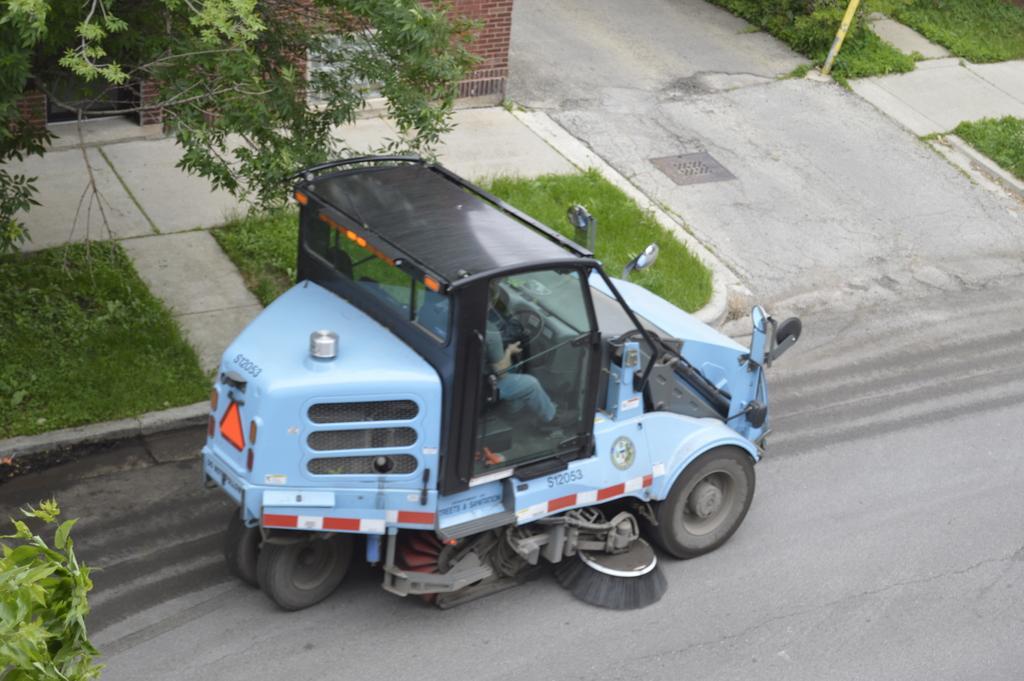How would you summarize this image in a sentence or two? In this image, we can see a person is riding a vehicle on the road. Here we can see grass, road, walkways, wall, pole, leaves and stems. 